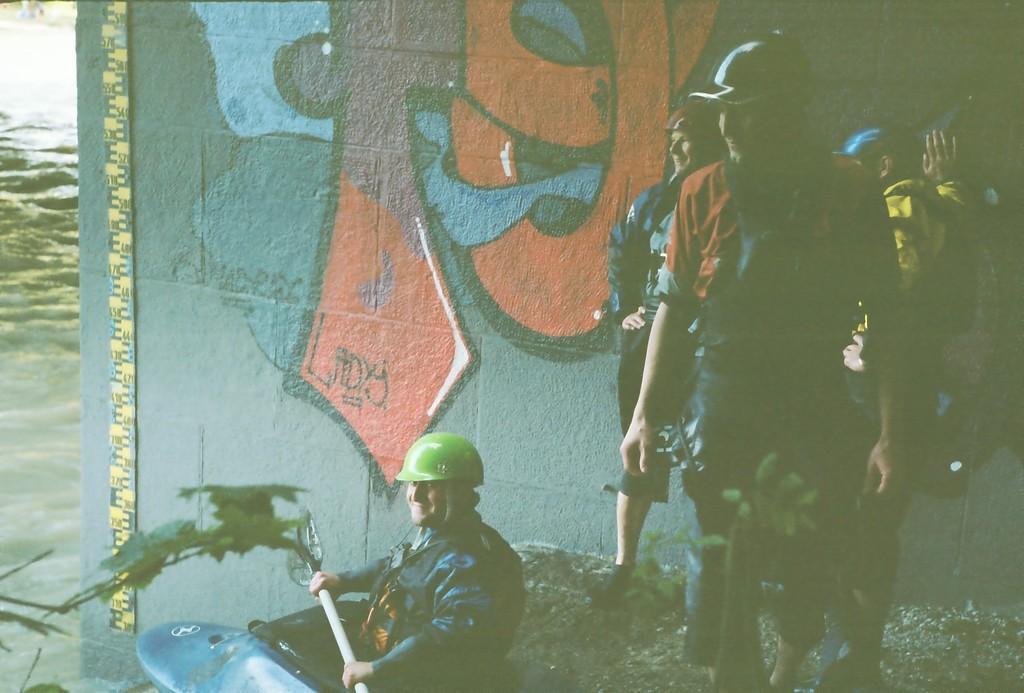Could you give a brief overview of what you see in this image? In this image there are some people standing on the mud beside the river in front of there is another man sitting in boat, behind the people there is a wall with graffiti. 